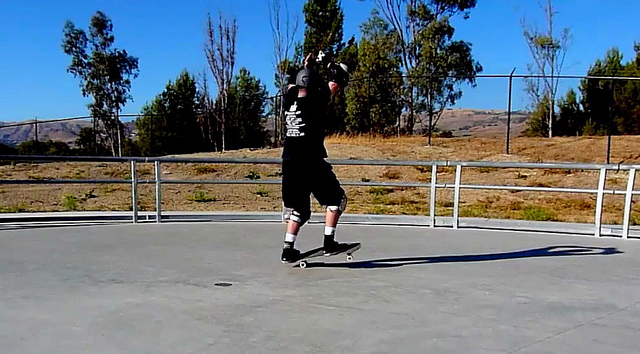Can you describe some popular skateboard tricks and their techniques? Certainly! Here are some popular skateboard tricks and their techniques:

1. **Ollie**: The Ollie is a fundamental trick where the skater jumps with the skateboard 'sticking' to their feet. Start by bending your knees, snap the tail down onto the ground, and jump. As you lift, slide your front foot forward to level the board in the air.

2. **Kickflip**: This trick involves flipping the skateboard horizontally. Begin with an Ollie, then flick your front foot off the board's side to make it spin. Catch the board with your feet as it completes the flip and land.

3. **Grind**: To perform a grind, jump to get your skateboard's trucks onto an edge (like a rail or curb) and slide along it. Approach at an angle, perform an Ollie, and land with the trucks making contact with the edge.

4. **Pop Shove-it**: Spin the board around its vertical axis without flipping. Start with an Ollie, then use your back foot to scoop the tail, making it spin. Catch the board with your feet and land.

5. **Manual**: This trick involves balancing on two wheels. Shift your weight to the back or front and lift the opposite end of the board while maintaining motion. For example, balance on the rear wheels for a regular manual, or on the front wheels for a nose manual.

Skateboarding is an expressive sport with endless tricks and combinations, making it both challenging and exciting. 